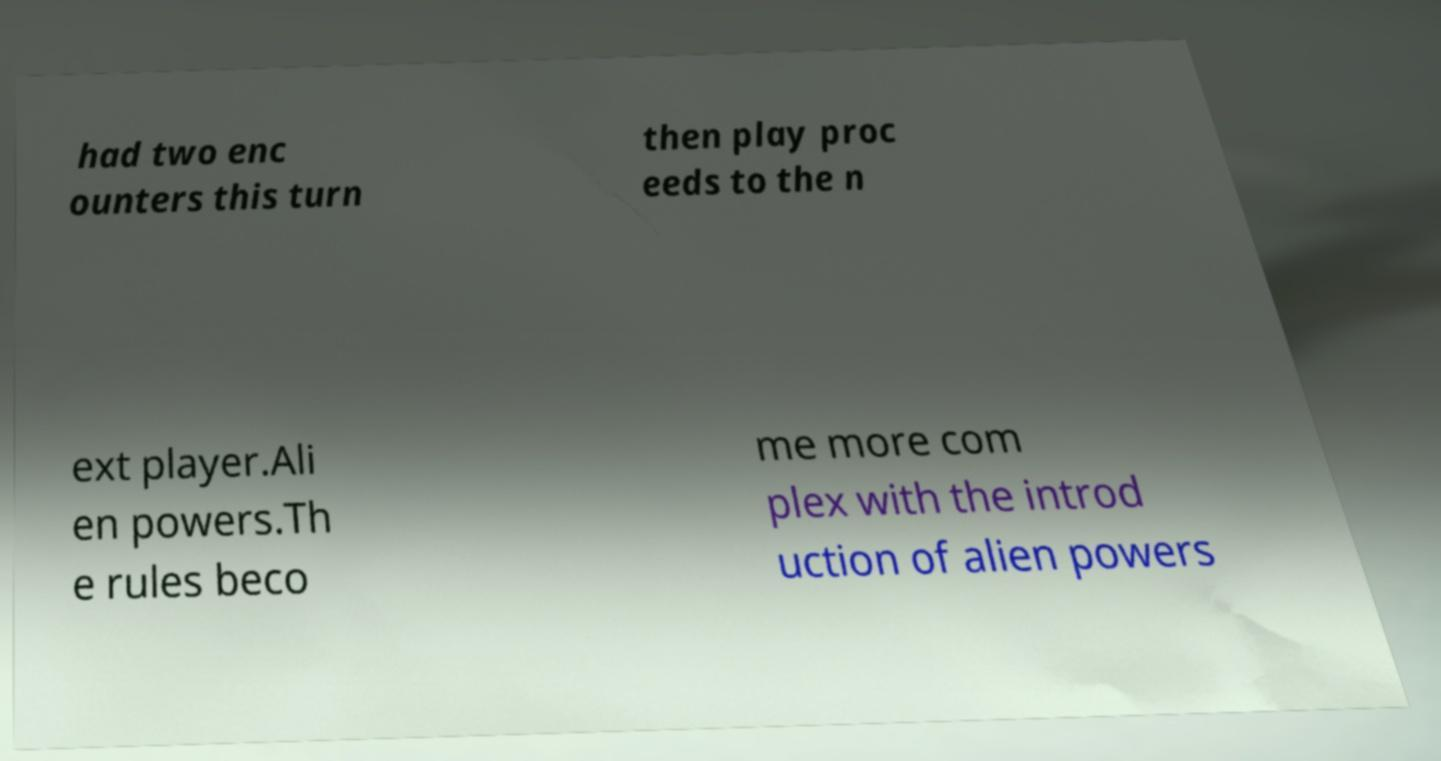Can you read and provide the text displayed in the image?This photo seems to have some interesting text. Can you extract and type it out for me? had two enc ounters this turn then play proc eeds to the n ext player.Ali en powers.Th e rules beco me more com plex with the introd uction of alien powers 